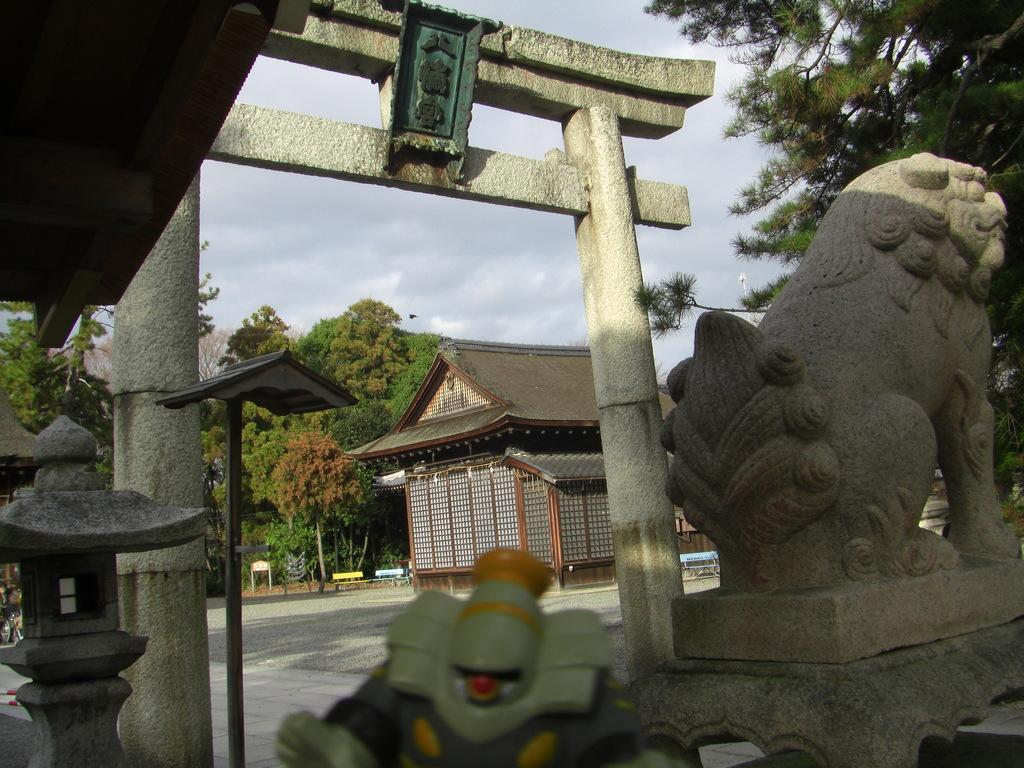What is located on the right side of the image? There is a statue on the right side of the image. What is beside the statue? There is an arch beside the statue. What is in the middle of the image? There is a house in the middle of the image. What type of vegetation is around the house? There are trees around the house. What is visible at the top of the image? The sky is visible at the top of the image. What is the name of the statue in the image? The provided facts do not mention the name of the statue, so it cannot be determined from the image. How does the statue express regret in the image? There is no indication in the image that the statue is expressing regret, as statues are inanimate objects and do not have emotions. 